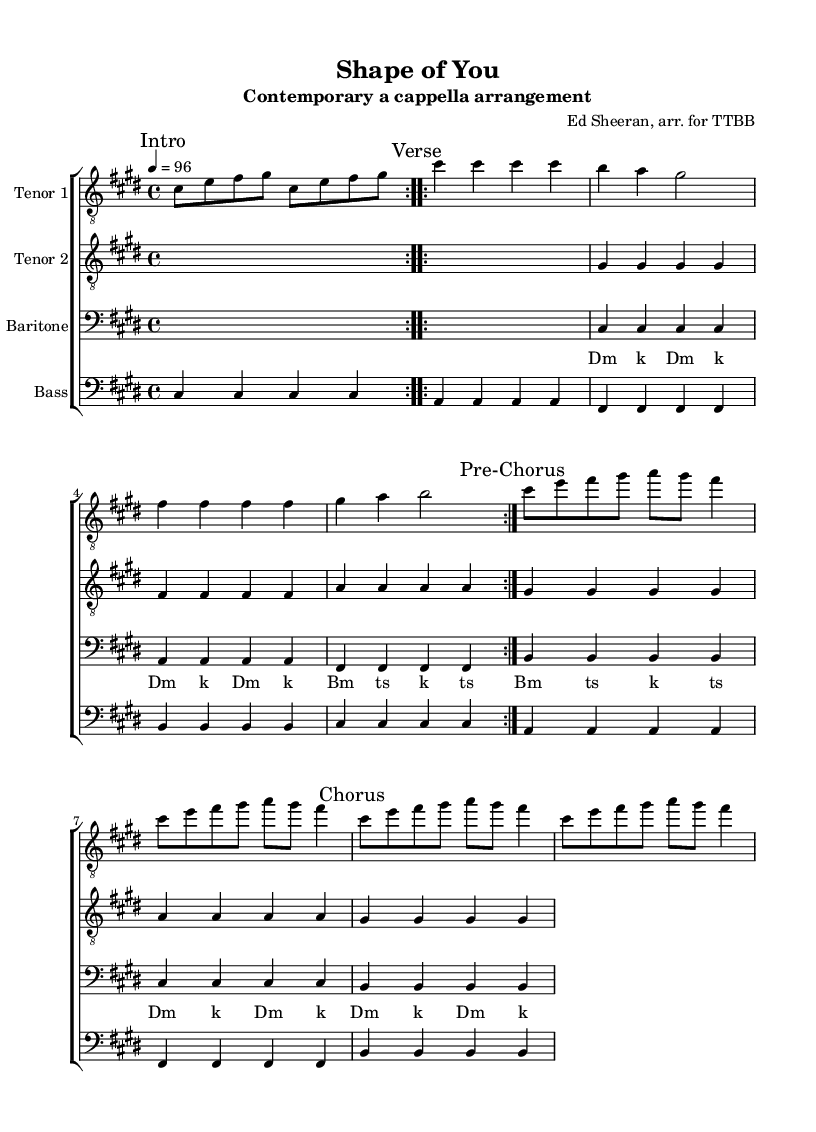What is the key signature of this music? The key signature shown in the music sheet indicates C# minor, which has four sharps (C#, D#, E, and F#, G#) based on the context in the global section.
Answer: C# minor What is the time signature of this music? The time signature is given in the global section as 4/4, meaning there are four beats in each measure, and the quarter note gets one beat.
Answer: 4/4 What is the tempo marking for this arrangement? The tempo marking specified in the global section is "4 = 96," indicating that there are 96 beats per minute when counting in quarter notes.
Answer: 96 How many measures are in the Chorus section? The Chorus section contains a total of two measures as indicated by the repeated note group and rests in the given part.
Answer: 2 measures What voice parts are included in this arrangement? The arrangement includes Tenor 1, Tenor 2, Baritone, and Bass, as evident from the different labeled staves in the score.
Answer: Tenor 1, Tenor 2, Baritone, Bass What vocal technique is used in the Baritone part? The Baritone part includes vocal sounds that mimic percussion, which is common in contemporary a cappella arrangements, as indicated by the rests and rhythmic patterns.
Answer: Vocal percussion Which part has a simplified harmony compared to the melody? The Tenor 2 part presents a simplified harmony line, as shown by the less complex rhythmic pattern compared to Tenor 1 which carries the melody.
Answer: Tenor 2 